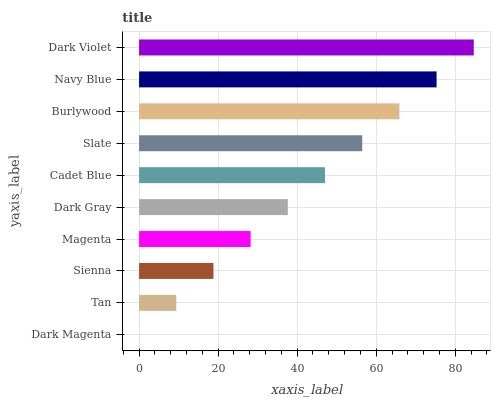Is Dark Magenta the minimum?
Answer yes or no. Yes. Is Dark Violet the maximum?
Answer yes or no. Yes. Is Tan the minimum?
Answer yes or no. No. Is Tan the maximum?
Answer yes or no. No. Is Tan greater than Dark Magenta?
Answer yes or no. Yes. Is Dark Magenta less than Tan?
Answer yes or no. Yes. Is Dark Magenta greater than Tan?
Answer yes or no. No. Is Tan less than Dark Magenta?
Answer yes or no. No. Is Cadet Blue the high median?
Answer yes or no. Yes. Is Dark Gray the low median?
Answer yes or no. Yes. Is Tan the high median?
Answer yes or no. No. Is Tan the low median?
Answer yes or no. No. 